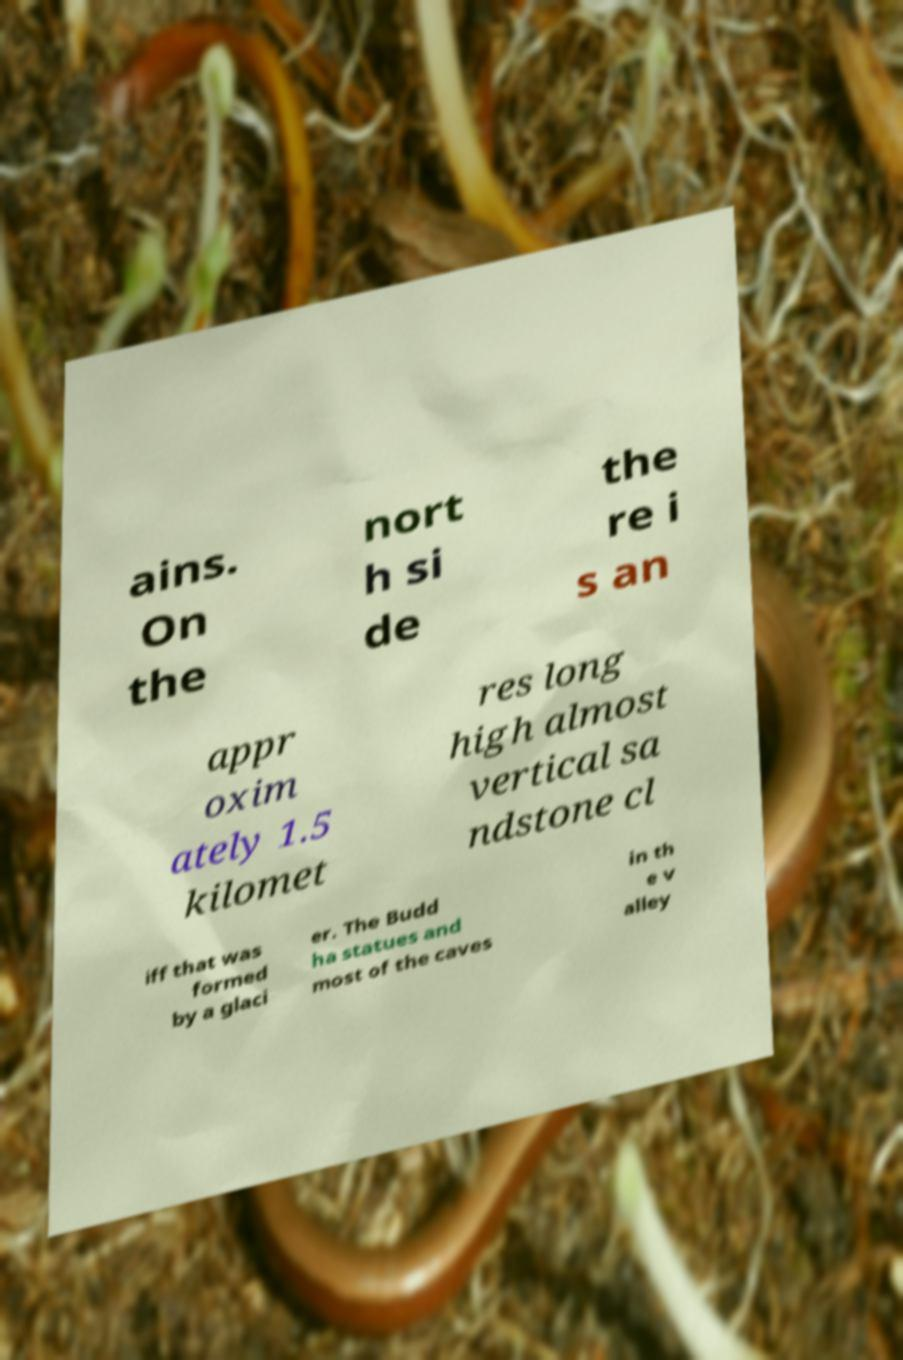Please identify and transcribe the text found in this image. ains. On the nort h si de the re i s an appr oxim ately 1.5 kilomet res long high almost vertical sa ndstone cl iff that was formed by a glaci er. The Budd ha statues and most of the caves in th e v alley 